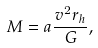<formula> <loc_0><loc_0><loc_500><loc_500>M = a \frac { v ^ { 2 } r _ { h } } { G } ,</formula> 